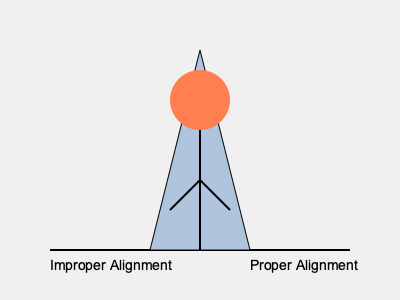In the context of seated meditation, which aspect of the body alignment shown in the diagram is most crucial for maintaining proper posture and facilitating extended periods of practice? To answer this question, let's analyze the diagram and consider the key elements of proper meditation posture:

1. Spine alignment: The central line in the triangle represents the spine. In proper alignment, this line should be straight and perpendicular to the ground.

2. Head position: The circle at the top represents the head. It should be balanced directly above the spine, neither tilted forward nor backward.

3. Hip angle: The base of the triangle represents the hips and sitting bones. The angle formed at the base is crucial for maintaining an upright posture.

4. Leg position: The lines extending from the central spine represent the legs. Their position affects overall stability and comfort.

5. Ground connection: The base of the triangle touching the horizontal line represents the connection to the ground or meditation cushion.

Among these elements, the spine alignment is the most crucial aspect for several reasons:

a) It supports the entire upper body structure.
b) Proper spine alignment allows for easier breathing and energy flow.
c) A straight spine reduces muscle tension and fatigue during extended meditation sessions.
d) It helps maintain alertness and prevents drowsiness.

The diagram clearly shows the difference between improper alignment (left) and proper alignment (right), emphasizing the importance of a straight, vertical spine.
Answer: Spine alignment 